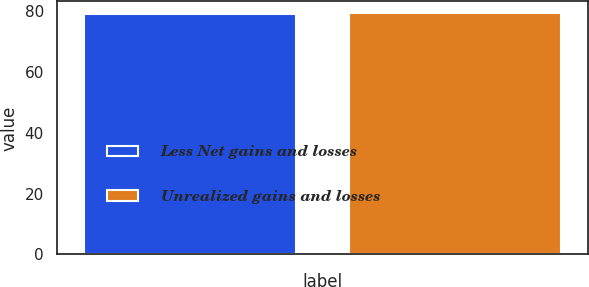Convert chart to OTSL. <chart><loc_0><loc_0><loc_500><loc_500><bar_chart><fcel>Less Net gains and losses<fcel>Unrealized gains and losses<nl><fcel>79<fcel>79.1<nl></chart> 